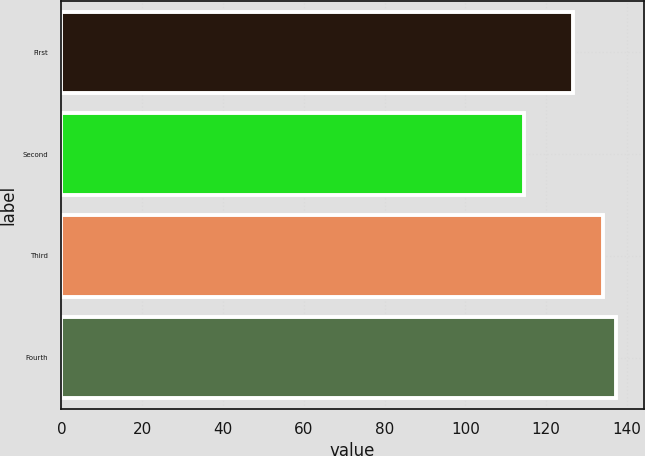<chart> <loc_0><loc_0><loc_500><loc_500><bar_chart><fcel>First<fcel>Second<fcel>Third<fcel>Fourth<nl><fcel>126.65<fcel>114.64<fcel>134.15<fcel>137.31<nl></chart> 